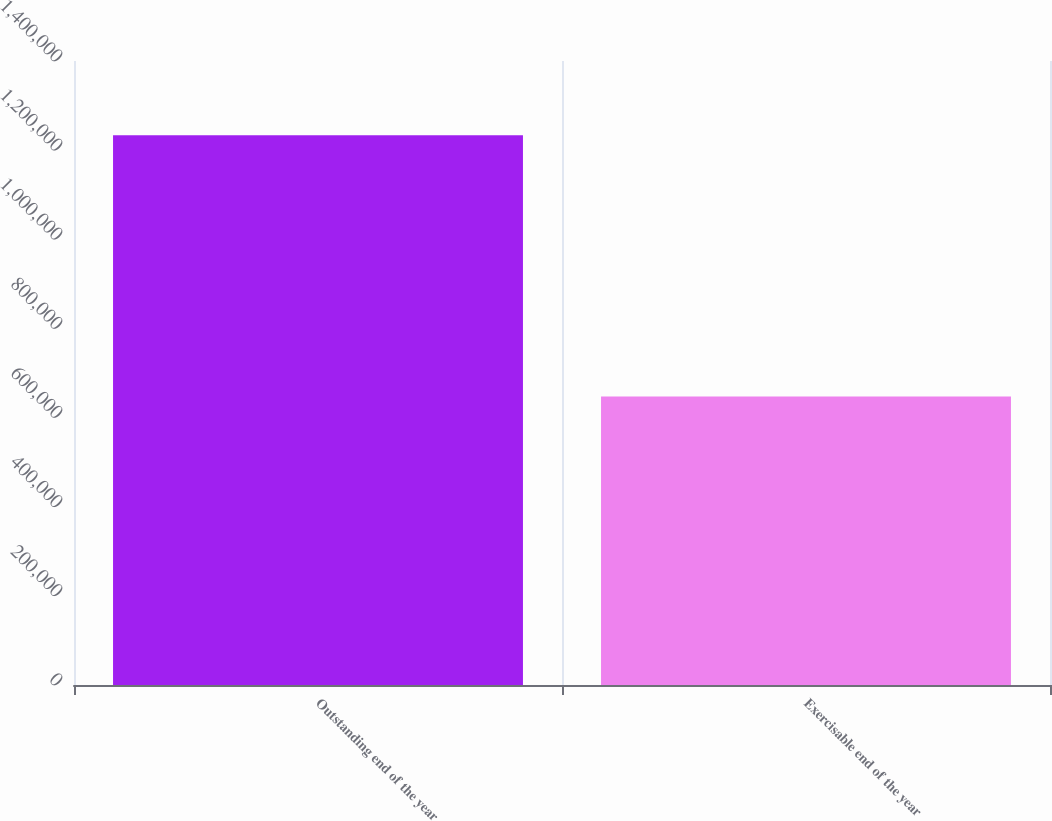Convert chart. <chart><loc_0><loc_0><loc_500><loc_500><bar_chart><fcel>Outstanding end of the year<fcel>Exercisable end of the year<nl><fcel>1.23367e+06<fcel>647425<nl></chart> 